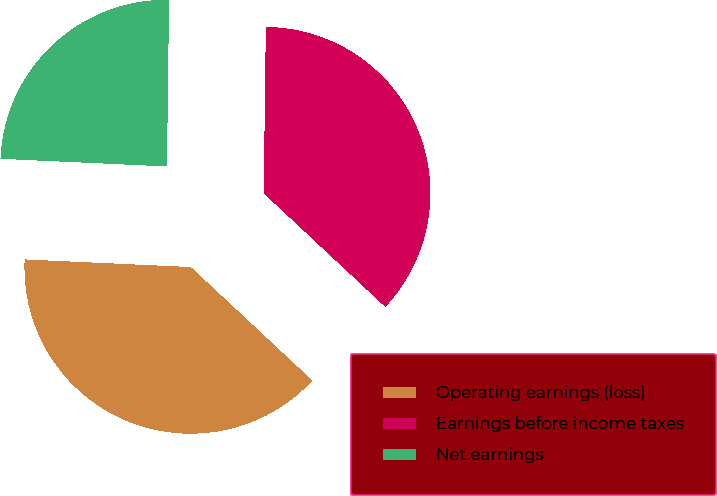Convert chart. <chart><loc_0><loc_0><loc_500><loc_500><pie_chart><fcel>Operating earnings (loss)<fcel>Earnings before income taxes<fcel>Net earnings<nl><fcel>38.77%<fcel>36.76%<fcel>24.47%<nl></chart> 